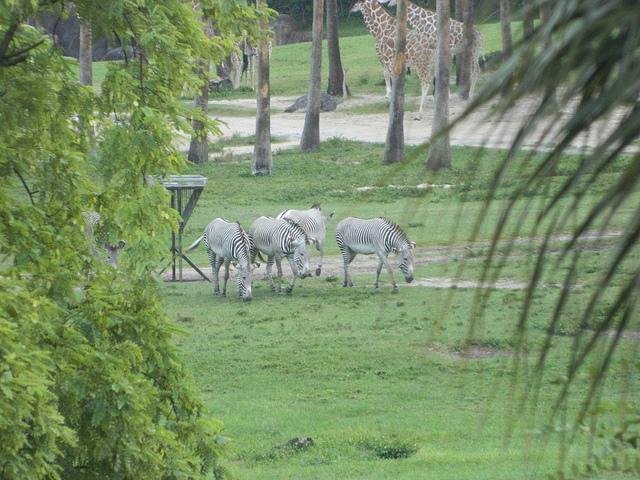Where are these Zebras most likely living together with the giraffes? Please explain your reasoning. conservatory. There are structures on the land and a road 